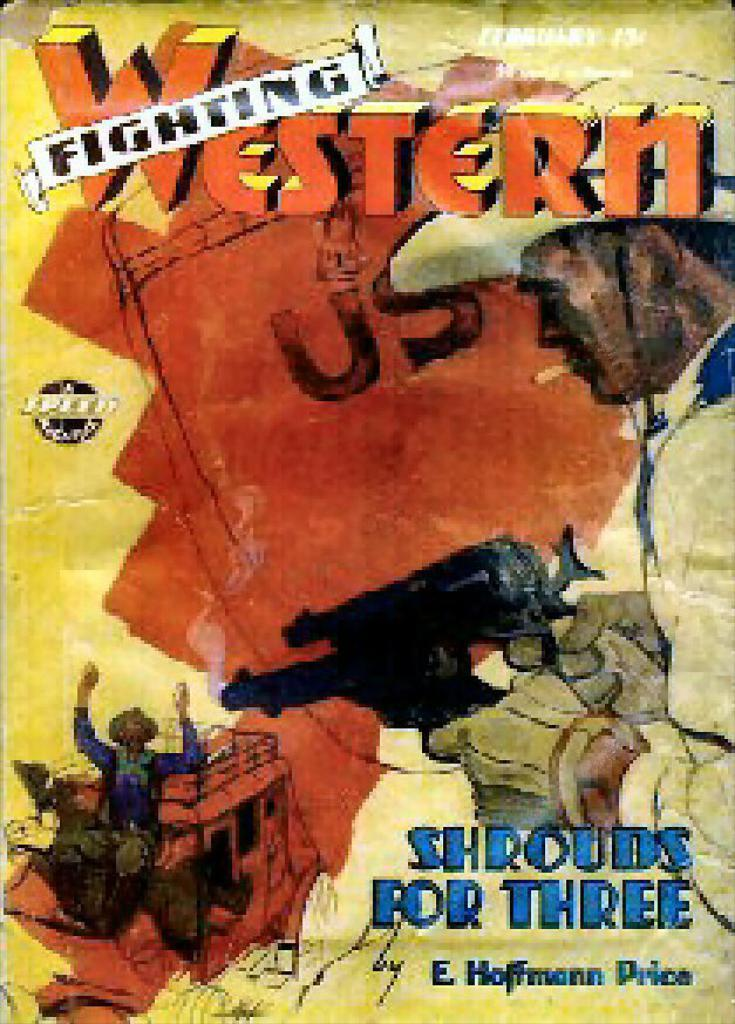Provide a one-sentence caption for the provided image. Animated cover of Fighting Western series called Shrouds For Three. 